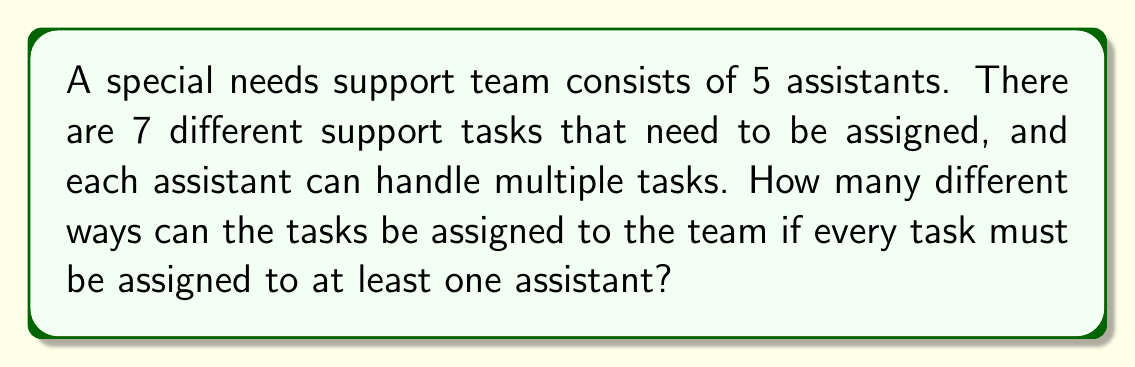Solve this math problem. Let's approach this step-by-step:

1) First, we need to understand that this is a problem of distributing tasks to assistants, where each task can be assigned to one or more assistants.

2) For each task, we have two options for each assistant: either they are assigned to the task or they are not. This creates a binary choice for each assistant per task.

3) With 5 assistants, each task has $2^5 = 32$ possible assignment configurations.

4) However, we need to exclude the case where a task is not assigned to any assistant. So for each task, we have 31 valid configurations (32 total - 1 invalid).

5) Now, we have 7 tasks, and each task can be independently assigned in 31 ways.

6) By the multiplication principle, the total number of ways to assign all 7 tasks is:

   $$ 31 \times 31 \times 31 \times 31 \times 31 \times 31 \times 31 = 31^7 $$

7) We can calculate this:
   $$ 31^7 = 27,512,614,111 $$

This large number reflects the flexibility in task assignment, which is crucial in special needs support to ensure each child receives personalized attention based on their specific requirements.
Answer: $31^7 = 27,512,614,111$ 